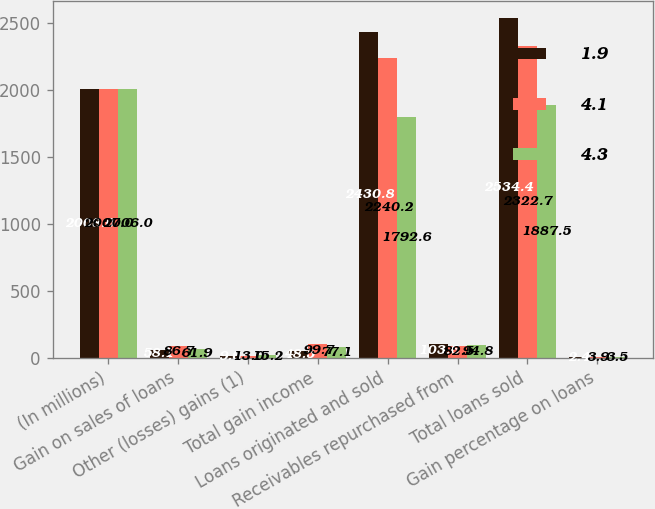<chart> <loc_0><loc_0><loc_500><loc_500><stacked_bar_chart><ecel><fcel>(In millions)<fcel>Gain on sales of loans<fcel>Other (losses) gains (1)<fcel>Total gain income<fcel>Loans originated and sold<fcel>Receivables repurchased from<fcel>Total loans sold<fcel>Gain percentage on loans<nl><fcel>1.9<fcel>2008<fcel>58.1<fcel>9.6<fcel>48.5<fcel>2430.8<fcel>103.6<fcel>2534.4<fcel>2.4<nl><fcel>4.1<fcel>2007<fcel>86.7<fcel>13<fcel>99.7<fcel>2240.2<fcel>82.5<fcel>2322.7<fcel>3.9<nl><fcel>4.3<fcel>2006<fcel>61.9<fcel>15.2<fcel>77.1<fcel>1792.6<fcel>94.8<fcel>1887.5<fcel>3.5<nl></chart> 